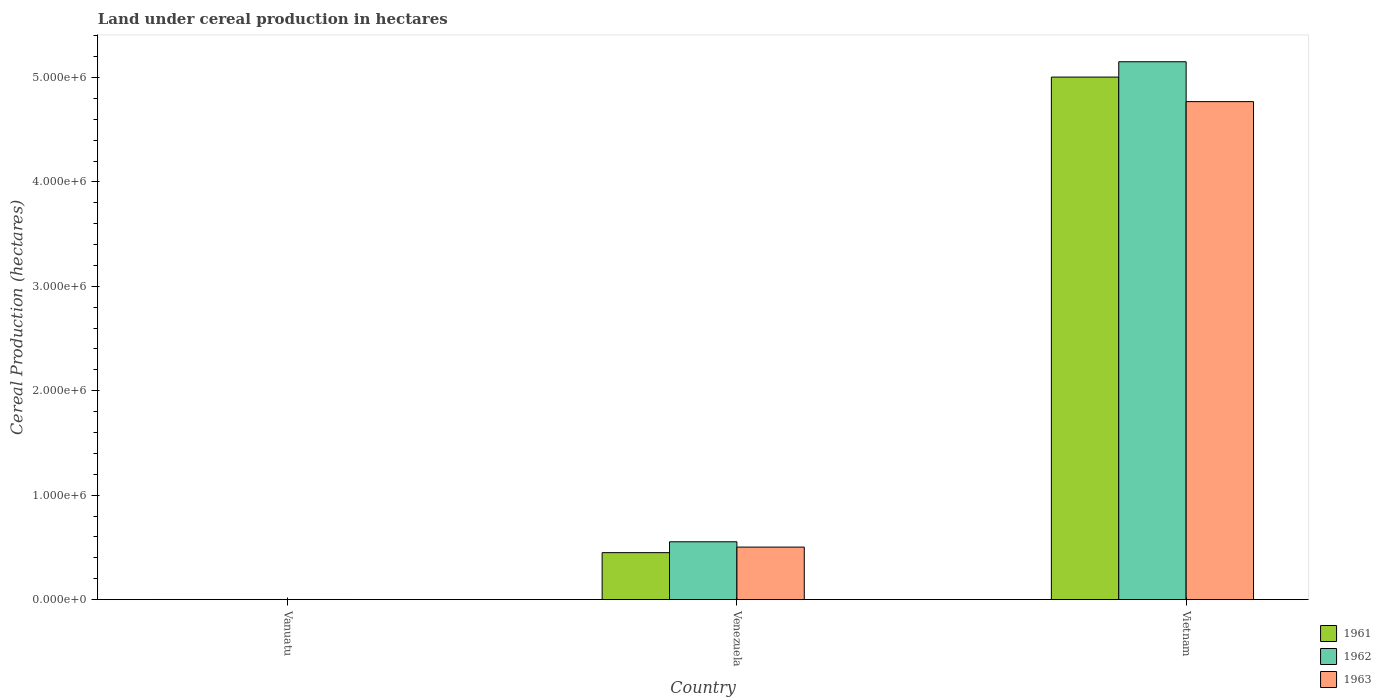How many groups of bars are there?
Make the answer very short. 3. How many bars are there on the 3rd tick from the right?
Your answer should be compact. 3. What is the label of the 1st group of bars from the left?
Your answer should be very brief. Vanuatu. In how many cases, is the number of bars for a given country not equal to the number of legend labels?
Ensure brevity in your answer.  0. What is the land under cereal production in 1962 in Venezuela?
Make the answer very short. 5.53e+05. Across all countries, what is the maximum land under cereal production in 1963?
Your answer should be compact. 4.77e+06. Across all countries, what is the minimum land under cereal production in 1962?
Give a very brief answer. 700. In which country was the land under cereal production in 1963 maximum?
Keep it short and to the point. Vietnam. In which country was the land under cereal production in 1963 minimum?
Give a very brief answer. Vanuatu. What is the total land under cereal production in 1962 in the graph?
Your response must be concise. 5.71e+06. What is the difference between the land under cereal production in 1961 in Vanuatu and that in Venezuela?
Offer a very short reply. -4.49e+05. What is the difference between the land under cereal production in 1963 in Venezuela and the land under cereal production in 1962 in Vietnam?
Your answer should be compact. -4.65e+06. What is the average land under cereal production in 1962 per country?
Make the answer very short. 1.90e+06. What is the difference between the land under cereal production of/in 1963 and land under cereal production of/in 1962 in Venezuela?
Make the answer very short. -5.09e+04. What is the ratio of the land under cereal production in 1961 in Venezuela to that in Vietnam?
Keep it short and to the point. 0.09. Is the land under cereal production in 1963 in Venezuela less than that in Vietnam?
Give a very brief answer. Yes. Is the difference between the land under cereal production in 1963 in Vanuatu and Vietnam greater than the difference between the land under cereal production in 1962 in Vanuatu and Vietnam?
Ensure brevity in your answer.  Yes. What is the difference between the highest and the second highest land under cereal production in 1962?
Provide a short and direct response. 5.15e+06. What is the difference between the highest and the lowest land under cereal production in 1963?
Make the answer very short. 4.77e+06. In how many countries, is the land under cereal production in 1961 greater than the average land under cereal production in 1961 taken over all countries?
Make the answer very short. 1. What does the 2nd bar from the left in Vanuatu represents?
Provide a succinct answer. 1962. Is it the case that in every country, the sum of the land under cereal production in 1963 and land under cereal production in 1962 is greater than the land under cereal production in 1961?
Make the answer very short. Yes. What is the difference between two consecutive major ticks on the Y-axis?
Give a very brief answer. 1.00e+06. How are the legend labels stacked?
Ensure brevity in your answer.  Vertical. What is the title of the graph?
Offer a terse response. Land under cereal production in hectares. What is the label or title of the X-axis?
Provide a succinct answer. Country. What is the label or title of the Y-axis?
Offer a terse response. Cereal Production (hectares). What is the Cereal Production (hectares) of 1961 in Vanuatu?
Your answer should be compact. 700. What is the Cereal Production (hectares) in 1962 in Vanuatu?
Give a very brief answer. 700. What is the Cereal Production (hectares) in 1963 in Vanuatu?
Ensure brevity in your answer.  700. What is the Cereal Production (hectares) in 1961 in Venezuela?
Your response must be concise. 4.49e+05. What is the Cereal Production (hectares) in 1962 in Venezuela?
Provide a short and direct response. 5.53e+05. What is the Cereal Production (hectares) in 1963 in Venezuela?
Make the answer very short. 5.03e+05. What is the Cereal Production (hectares) in 1961 in Vietnam?
Your answer should be compact. 5.00e+06. What is the Cereal Production (hectares) in 1962 in Vietnam?
Provide a short and direct response. 5.15e+06. What is the Cereal Production (hectares) in 1963 in Vietnam?
Offer a terse response. 4.77e+06. Across all countries, what is the maximum Cereal Production (hectares) of 1961?
Your answer should be very brief. 5.00e+06. Across all countries, what is the maximum Cereal Production (hectares) of 1962?
Provide a succinct answer. 5.15e+06. Across all countries, what is the maximum Cereal Production (hectares) in 1963?
Make the answer very short. 4.77e+06. Across all countries, what is the minimum Cereal Production (hectares) in 1961?
Make the answer very short. 700. Across all countries, what is the minimum Cereal Production (hectares) in 1962?
Provide a short and direct response. 700. Across all countries, what is the minimum Cereal Production (hectares) in 1963?
Offer a terse response. 700. What is the total Cereal Production (hectares) of 1961 in the graph?
Provide a succinct answer. 5.45e+06. What is the total Cereal Production (hectares) of 1962 in the graph?
Provide a succinct answer. 5.71e+06. What is the total Cereal Production (hectares) in 1963 in the graph?
Offer a terse response. 5.27e+06. What is the difference between the Cereal Production (hectares) of 1961 in Vanuatu and that in Venezuela?
Ensure brevity in your answer.  -4.49e+05. What is the difference between the Cereal Production (hectares) in 1962 in Vanuatu and that in Venezuela?
Your answer should be very brief. -5.53e+05. What is the difference between the Cereal Production (hectares) of 1963 in Vanuatu and that in Venezuela?
Your answer should be very brief. -5.02e+05. What is the difference between the Cereal Production (hectares) of 1961 in Vanuatu and that in Vietnam?
Make the answer very short. -5.00e+06. What is the difference between the Cereal Production (hectares) of 1962 in Vanuatu and that in Vietnam?
Your answer should be compact. -5.15e+06. What is the difference between the Cereal Production (hectares) of 1963 in Vanuatu and that in Vietnam?
Ensure brevity in your answer.  -4.77e+06. What is the difference between the Cereal Production (hectares) in 1961 in Venezuela and that in Vietnam?
Offer a terse response. -4.55e+06. What is the difference between the Cereal Production (hectares) of 1962 in Venezuela and that in Vietnam?
Make the answer very short. -4.60e+06. What is the difference between the Cereal Production (hectares) of 1963 in Venezuela and that in Vietnam?
Offer a very short reply. -4.27e+06. What is the difference between the Cereal Production (hectares) of 1961 in Vanuatu and the Cereal Production (hectares) of 1962 in Venezuela?
Provide a short and direct response. -5.53e+05. What is the difference between the Cereal Production (hectares) in 1961 in Vanuatu and the Cereal Production (hectares) in 1963 in Venezuela?
Offer a very short reply. -5.02e+05. What is the difference between the Cereal Production (hectares) in 1962 in Vanuatu and the Cereal Production (hectares) in 1963 in Venezuela?
Provide a short and direct response. -5.02e+05. What is the difference between the Cereal Production (hectares) of 1961 in Vanuatu and the Cereal Production (hectares) of 1962 in Vietnam?
Give a very brief answer. -5.15e+06. What is the difference between the Cereal Production (hectares) in 1961 in Vanuatu and the Cereal Production (hectares) in 1963 in Vietnam?
Your response must be concise. -4.77e+06. What is the difference between the Cereal Production (hectares) of 1962 in Vanuatu and the Cereal Production (hectares) of 1963 in Vietnam?
Your response must be concise. -4.77e+06. What is the difference between the Cereal Production (hectares) in 1961 in Venezuela and the Cereal Production (hectares) in 1962 in Vietnam?
Provide a succinct answer. -4.70e+06. What is the difference between the Cereal Production (hectares) of 1961 in Venezuela and the Cereal Production (hectares) of 1963 in Vietnam?
Make the answer very short. -4.32e+06. What is the difference between the Cereal Production (hectares) in 1962 in Venezuela and the Cereal Production (hectares) in 1963 in Vietnam?
Your response must be concise. -4.22e+06. What is the average Cereal Production (hectares) of 1961 per country?
Give a very brief answer. 1.82e+06. What is the average Cereal Production (hectares) of 1962 per country?
Your answer should be compact. 1.90e+06. What is the average Cereal Production (hectares) of 1963 per country?
Your answer should be compact. 1.76e+06. What is the difference between the Cereal Production (hectares) in 1961 and Cereal Production (hectares) in 1962 in Vanuatu?
Your response must be concise. 0. What is the difference between the Cereal Production (hectares) of 1962 and Cereal Production (hectares) of 1963 in Vanuatu?
Offer a terse response. 0. What is the difference between the Cereal Production (hectares) in 1961 and Cereal Production (hectares) in 1962 in Venezuela?
Your answer should be compact. -1.04e+05. What is the difference between the Cereal Production (hectares) in 1961 and Cereal Production (hectares) in 1963 in Venezuela?
Your answer should be compact. -5.31e+04. What is the difference between the Cereal Production (hectares) in 1962 and Cereal Production (hectares) in 1963 in Venezuela?
Ensure brevity in your answer.  5.09e+04. What is the difference between the Cereal Production (hectares) in 1961 and Cereal Production (hectares) in 1962 in Vietnam?
Your answer should be very brief. -1.47e+05. What is the difference between the Cereal Production (hectares) of 1961 and Cereal Production (hectares) of 1963 in Vietnam?
Ensure brevity in your answer.  2.35e+05. What is the difference between the Cereal Production (hectares) in 1962 and Cereal Production (hectares) in 1963 in Vietnam?
Offer a very short reply. 3.82e+05. What is the ratio of the Cereal Production (hectares) in 1961 in Vanuatu to that in Venezuela?
Offer a very short reply. 0. What is the ratio of the Cereal Production (hectares) in 1962 in Vanuatu to that in Venezuela?
Your response must be concise. 0. What is the ratio of the Cereal Production (hectares) in 1963 in Vanuatu to that in Venezuela?
Provide a short and direct response. 0. What is the ratio of the Cereal Production (hectares) in 1961 in Vanuatu to that in Vietnam?
Your answer should be very brief. 0. What is the ratio of the Cereal Production (hectares) in 1962 in Vanuatu to that in Vietnam?
Give a very brief answer. 0. What is the ratio of the Cereal Production (hectares) of 1963 in Vanuatu to that in Vietnam?
Provide a succinct answer. 0. What is the ratio of the Cereal Production (hectares) of 1961 in Venezuela to that in Vietnam?
Your answer should be very brief. 0.09. What is the ratio of the Cereal Production (hectares) in 1962 in Venezuela to that in Vietnam?
Your answer should be very brief. 0.11. What is the ratio of the Cereal Production (hectares) of 1963 in Venezuela to that in Vietnam?
Give a very brief answer. 0.11. What is the difference between the highest and the second highest Cereal Production (hectares) in 1961?
Your response must be concise. 4.55e+06. What is the difference between the highest and the second highest Cereal Production (hectares) of 1962?
Give a very brief answer. 4.60e+06. What is the difference between the highest and the second highest Cereal Production (hectares) of 1963?
Offer a very short reply. 4.27e+06. What is the difference between the highest and the lowest Cereal Production (hectares) in 1961?
Give a very brief answer. 5.00e+06. What is the difference between the highest and the lowest Cereal Production (hectares) of 1962?
Provide a short and direct response. 5.15e+06. What is the difference between the highest and the lowest Cereal Production (hectares) in 1963?
Provide a short and direct response. 4.77e+06. 